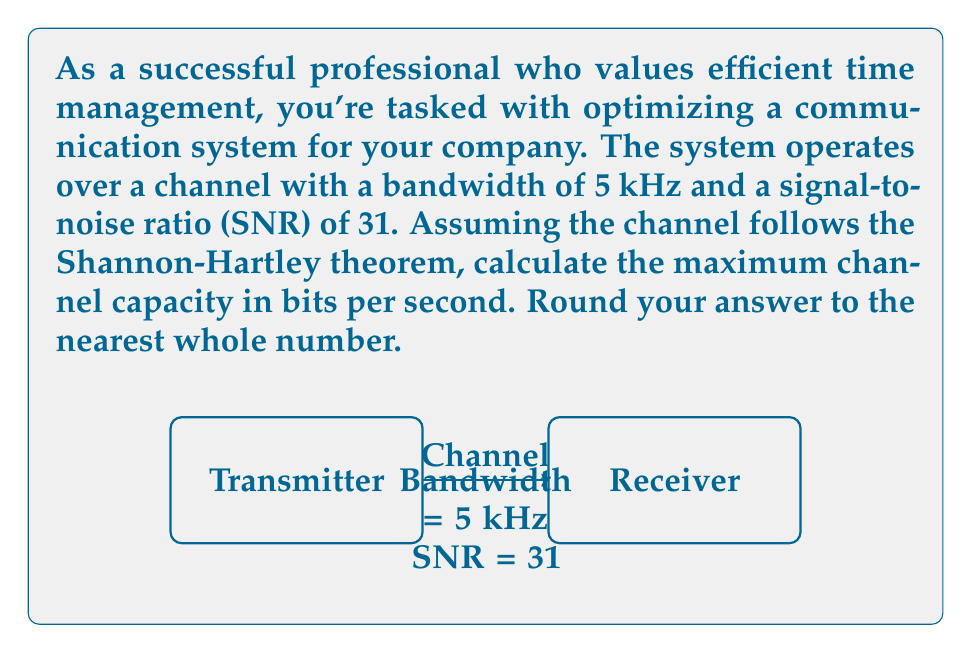Could you help me with this problem? To solve this problem, we'll use the Shannon-Hartley theorem, which gives the channel capacity for a noisy communication channel. The theorem states:

$$ C = B \log_2(1 + SNR) $$

Where:
- $C$ is the channel capacity in bits per second
- $B$ is the bandwidth in Hz
- $SNR$ is the signal-to-noise ratio

Given:
- Bandwidth, $B = 5$ kHz = 5000 Hz
- Signal-to-Noise Ratio, $SNR = 31$

Let's substitute these values into the formula:

$$ C = 5000 \log_2(1 + 31) $$

Now, let's calculate step by step:

1) First, calculate $(1 + 31)$:
   $1 + 31 = 32$

2) Then, calculate $\log_2(32)$:
   $\log_2(32) = 5$

3) Multiply the result by the bandwidth:
   $C = 5000 \cdot 5 = 25000$ bits per second

4) Round to the nearest whole number:
   $C \approx 25000$ bits per second

Thus, the maximum channel capacity is approximately 25000 bits per second.
Answer: 25000 bits/s 